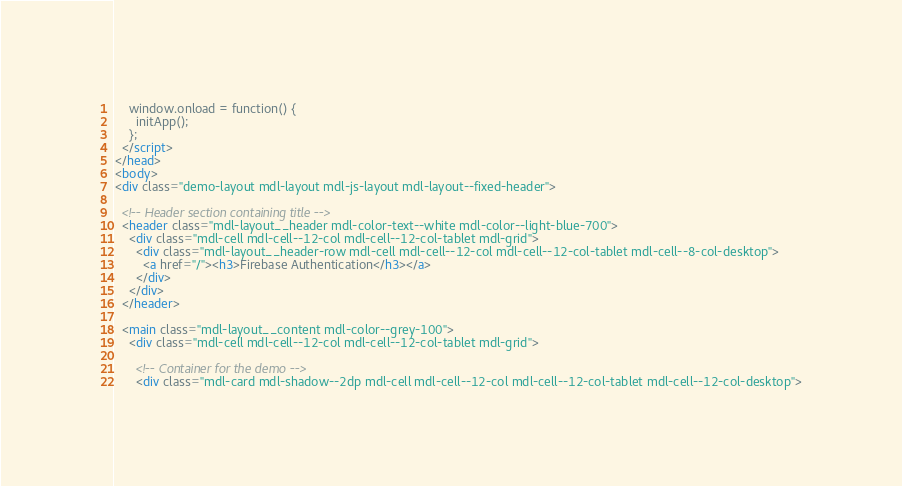Convert code to text. <code><loc_0><loc_0><loc_500><loc_500><_HTML_>    window.onload = function() {
      initApp();
    };
  </script>
</head>
<body>
<div class="demo-layout mdl-layout mdl-js-layout mdl-layout--fixed-header">

  <!-- Header section containing title -->
  <header class="mdl-layout__header mdl-color-text--white mdl-color--light-blue-700">
    <div class="mdl-cell mdl-cell--12-col mdl-cell--12-col-tablet mdl-grid">
      <div class="mdl-layout__header-row mdl-cell mdl-cell--12-col mdl-cell--12-col-tablet mdl-cell--8-col-desktop">
        <a href="/"><h3>Firebase Authentication</h3></a>
      </div>
    </div>
  </header>

  <main class="mdl-layout__content mdl-color--grey-100">
    <div class="mdl-cell mdl-cell--12-col mdl-cell--12-col-tablet mdl-grid">

      <!-- Container for the demo -->
      <div class="mdl-card mdl-shadow--2dp mdl-cell mdl-cell--12-col mdl-cell--12-col-tablet mdl-cell--12-col-desktop"></code> 